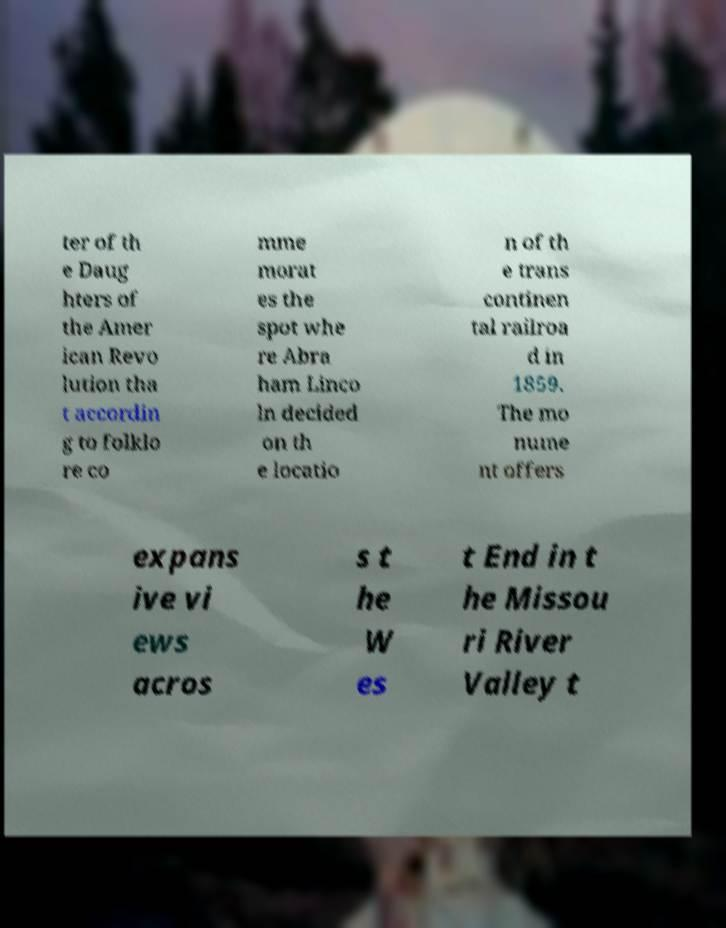For documentation purposes, I need the text within this image transcribed. Could you provide that? ter of th e Daug hters of the Amer ican Revo lution tha t accordin g to folklo re co mme morat es the spot whe re Abra ham Linco ln decided on th e locatio n of th e trans continen tal railroa d in 1859. The mo nume nt offers expans ive vi ews acros s t he W es t End in t he Missou ri River Valley t 